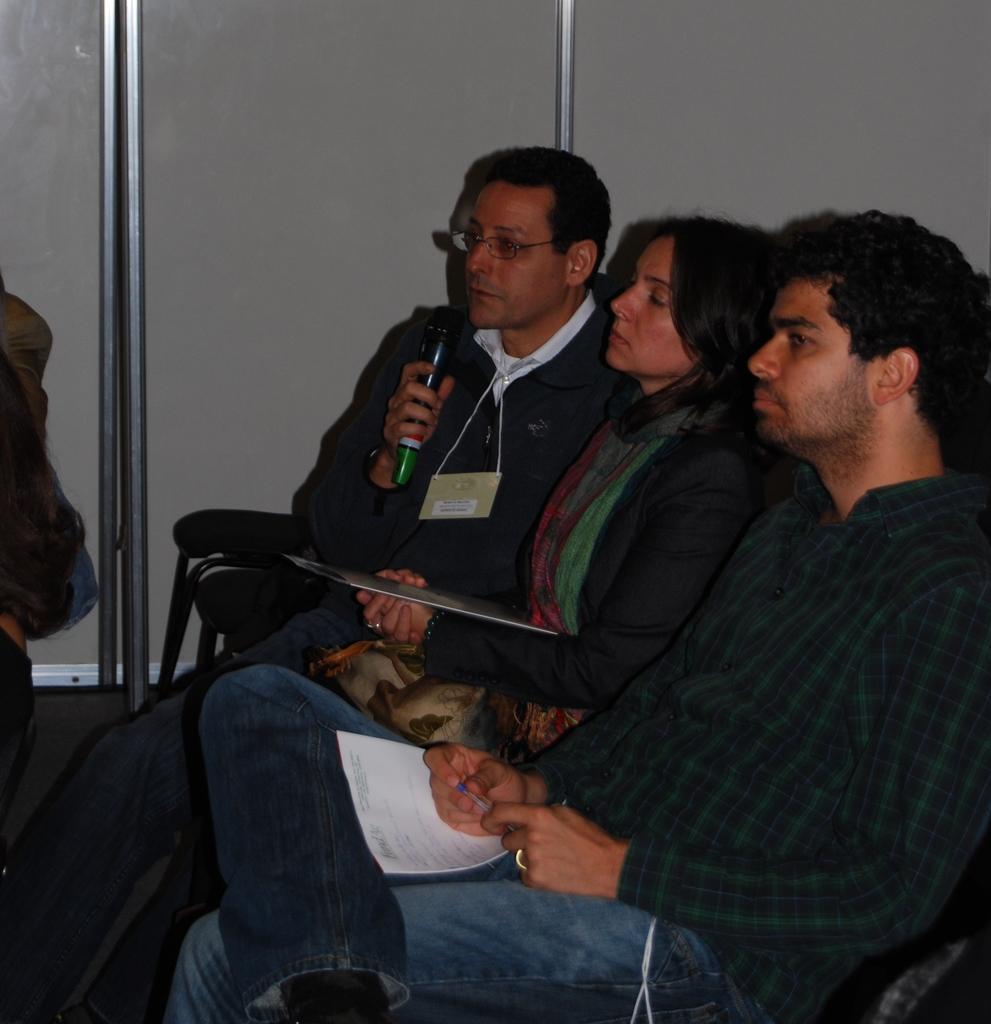Could you give a brief overview of what you see in this image? In this image there are a few people sitting on the chairs in which one of them holds a microphone, some of them are holding papers and there is a wooden wall. 